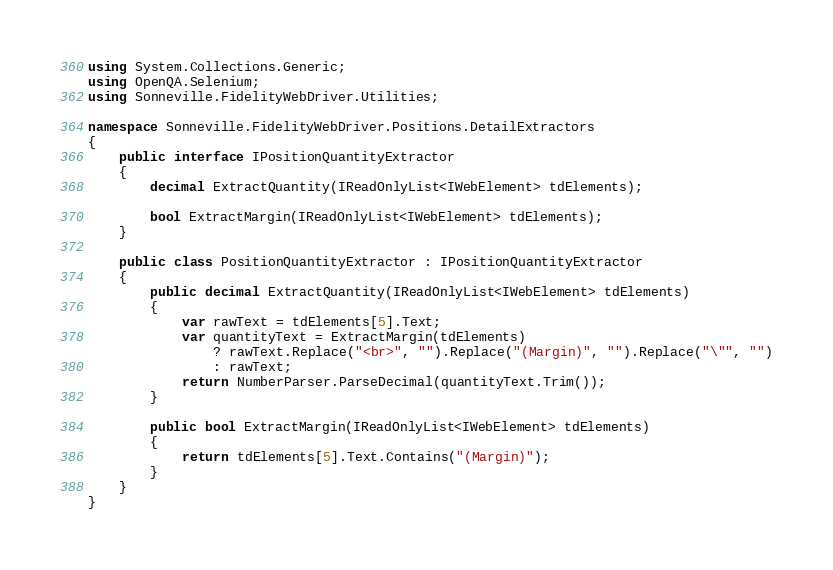<code> <loc_0><loc_0><loc_500><loc_500><_C#_>using System.Collections.Generic;
using OpenQA.Selenium;
using Sonneville.FidelityWebDriver.Utilities;

namespace Sonneville.FidelityWebDriver.Positions.DetailExtractors
{
    public interface IPositionQuantityExtractor
    {
        decimal ExtractQuantity(IReadOnlyList<IWebElement> tdElements);

        bool ExtractMargin(IReadOnlyList<IWebElement> tdElements);
    }

    public class PositionQuantityExtractor : IPositionQuantityExtractor
    {
        public decimal ExtractQuantity(IReadOnlyList<IWebElement> tdElements)
        {
            var rawText = tdElements[5].Text;
            var quantityText = ExtractMargin(tdElements)
                ? rawText.Replace("<br>", "").Replace("(Margin)", "").Replace("\"", "")
                : rawText;
            return NumberParser.ParseDecimal(quantityText.Trim());
        }

        public bool ExtractMargin(IReadOnlyList<IWebElement> tdElements)
        {
            return tdElements[5].Text.Contains("(Margin)");
        }
    }
}</code> 